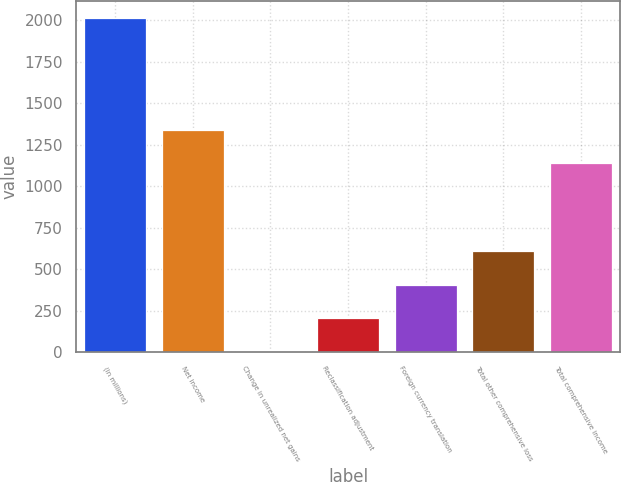Convert chart to OTSL. <chart><loc_0><loc_0><loc_500><loc_500><bar_chart><fcel>(In millions)<fcel>Net income<fcel>Change in unrealized net gains<fcel>Reclassification adjustment<fcel>Foreign currency translation<fcel>Total other comprehensive loss<fcel>Total comprehensive income<nl><fcel>2016<fcel>1339.1<fcel>5<fcel>206.1<fcel>407.2<fcel>608.3<fcel>1138<nl></chart> 